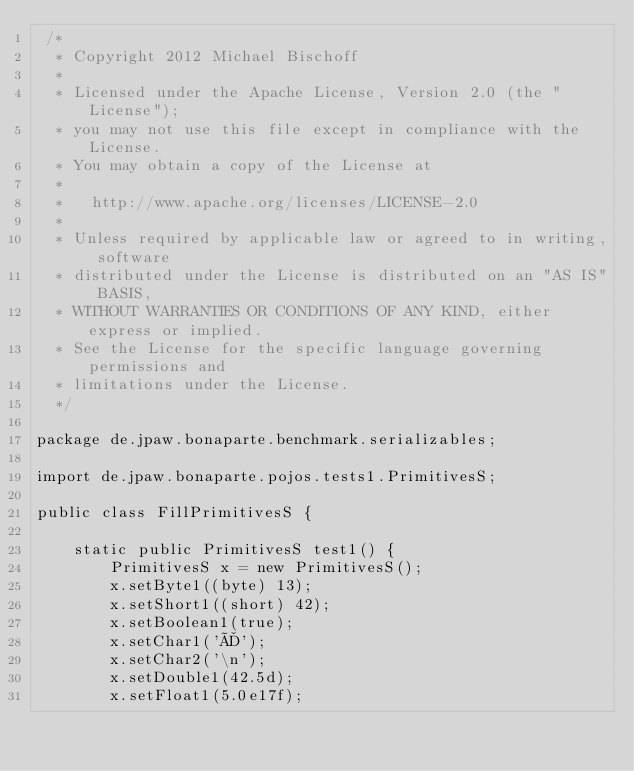Convert code to text. <code><loc_0><loc_0><loc_500><loc_500><_Java_> /*
  * Copyright 2012 Michael Bischoff
  *
  * Licensed under the Apache License, Version 2.0 (the "License");
  * you may not use this file except in compliance with the License.
  * You may obtain a copy of the License at
  *
  *   http://www.apache.org/licenses/LICENSE-2.0
  *
  * Unless required by applicable law or agreed to in writing, software
  * distributed under the License is distributed on an "AS IS" BASIS,
  * WITHOUT WARRANTIES OR CONDITIONS OF ANY KIND, either express or implied.
  * See the License for the specific language governing permissions and
  * limitations under the License.
  */

package de.jpaw.bonaparte.benchmark.serializables;

import de.jpaw.bonaparte.pojos.tests1.PrimitivesS;

public class FillPrimitivesS {

    static public PrimitivesS test1() {
        PrimitivesS x = new PrimitivesS();
        x.setByte1((byte) 13);
        x.setShort1((short) 42);
        x.setBoolean1(true);
        x.setChar1('Ä');
        x.setChar2('\n');
        x.setDouble1(42.5d);
        x.setFloat1(5.0e17f);</code> 